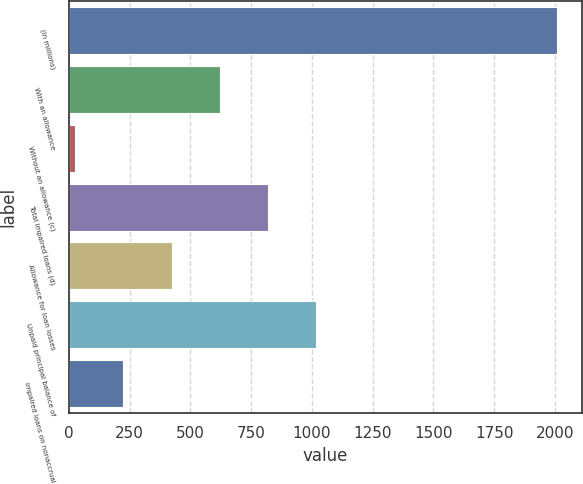Convert chart. <chart><loc_0><loc_0><loc_500><loc_500><bar_chart><fcel>(in millions)<fcel>With an allowance<fcel>Without an allowance (c)<fcel>Total impaired loans (d)<fcel>Allowance for loan losses<fcel>Unpaid principal balance of<fcel>Impaired loans on nonaccrual<nl><fcel>2010<fcel>620.5<fcel>25<fcel>819<fcel>422<fcel>1017.5<fcel>223.5<nl></chart> 